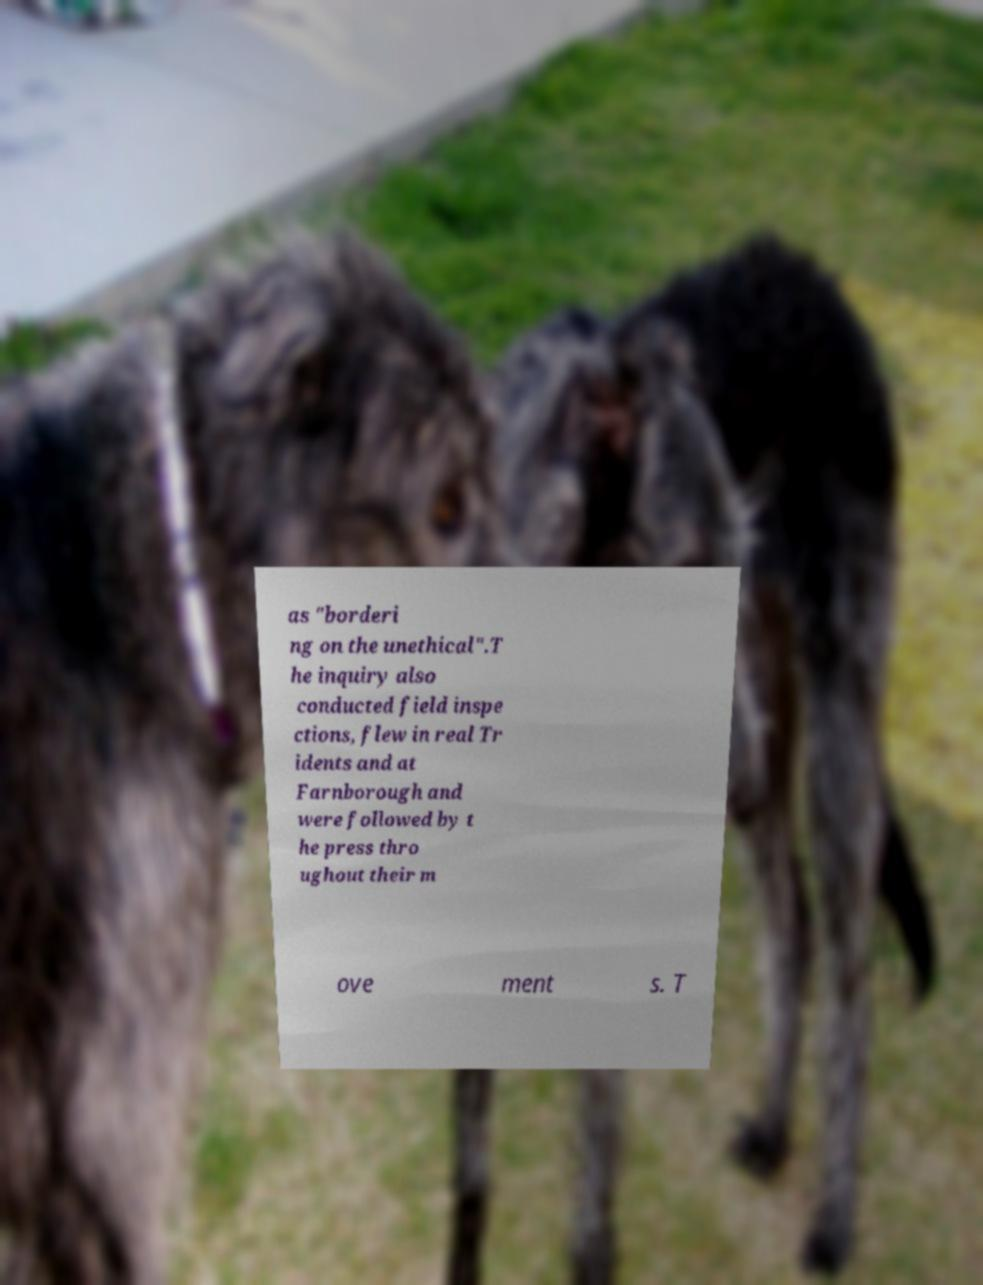I need the written content from this picture converted into text. Can you do that? as "borderi ng on the unethical".T he inquiry also conducted field inspe ctions, flew in real Tr idents and at Farnborough and were followed by t he press thro ughout their m ove ment s. T 